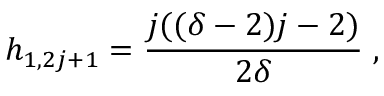<formula> <loc_0><loc_0><loc_500><loc_500>h _ { 1 , 2 j + 1 } = \frac { j ( ( \delta - 2 ) j - 2 ) } { 2 \delta } \, ,</formula> 